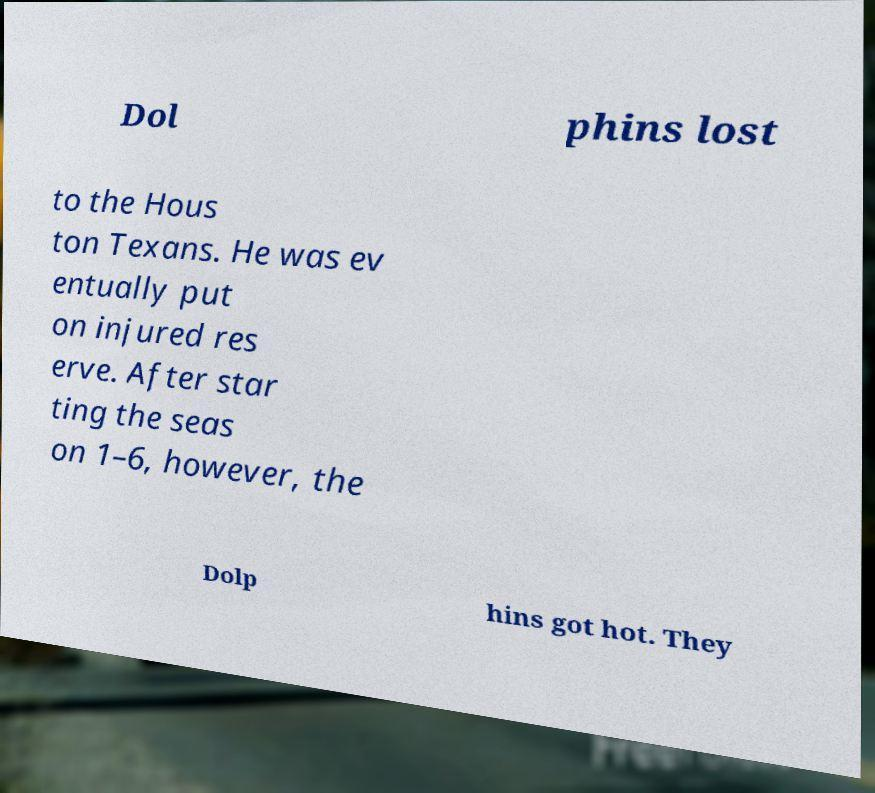For documentation purposes, I need the text within this image transcribed. Could you provide that? Dol phins lost to the Hous ton Texans. He was ev entually put on injured res erve. After star ting the seas on 1–6, however, the Dolp hins got hot. They 